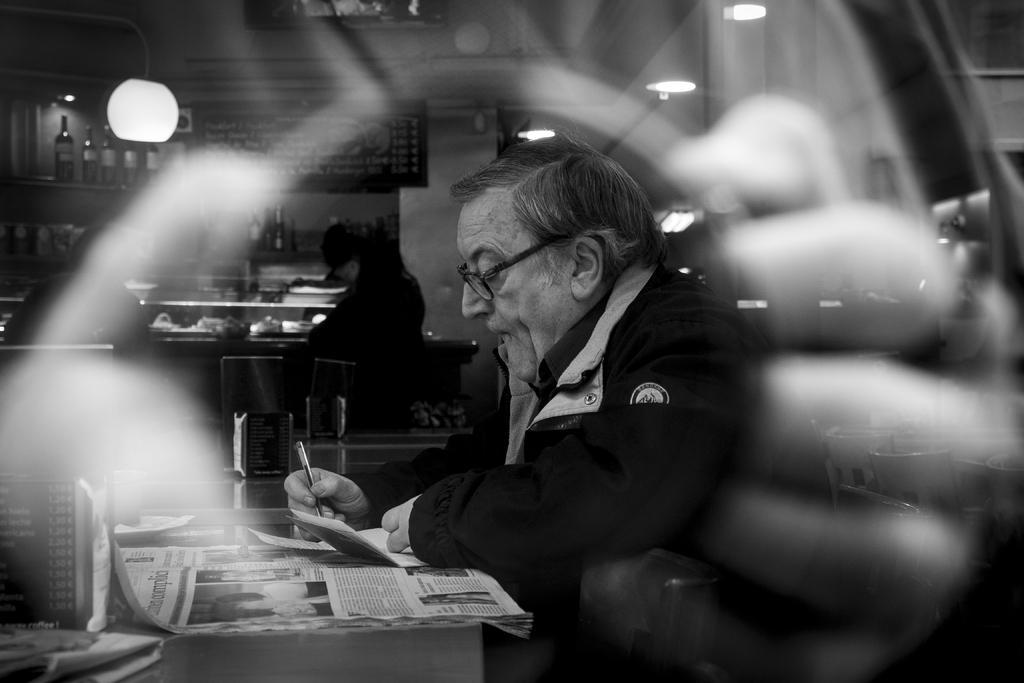Please provide a concise description of this image. In this picture we can see a man wore spectacle writing something on the paper with pen and in front of him is a table and in background we can see bottles, a person sitting over there, and some racks, poster, bulb, lights and pillar. 